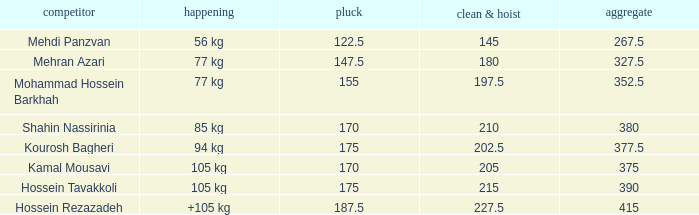What is the total that had an event of +105 kg and clean & jerk less than 227.5? 0.0. 